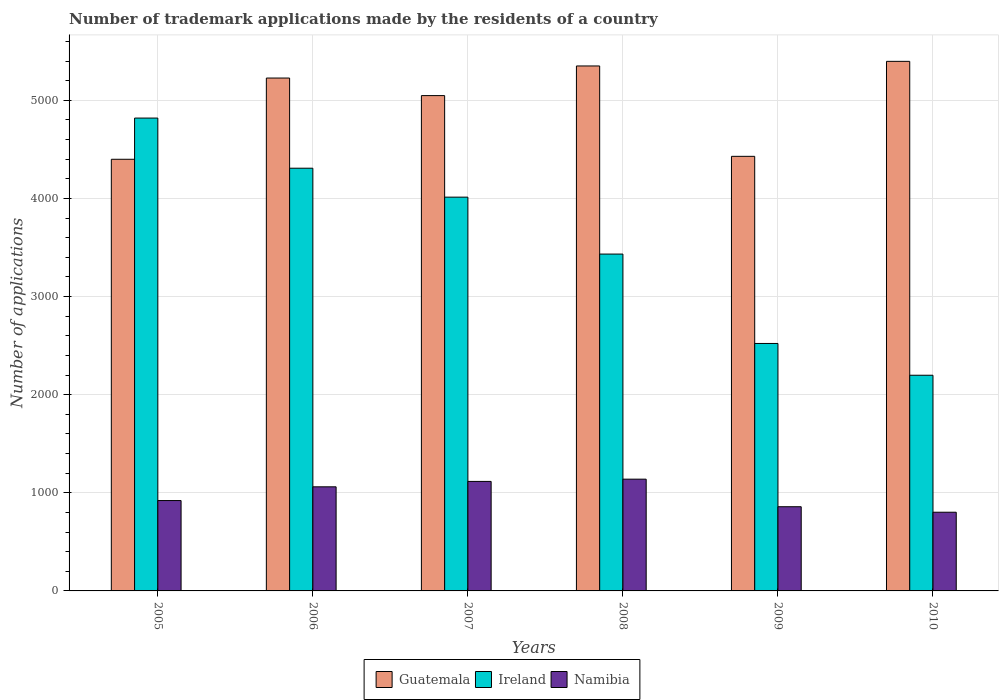Are the number of bars per tick equal to the number of legend labels?
Your answer should be very brief. Yes. Are the number of bars on each tick of the X-axis equal?
Keep it short and to the point. Yes. How many bars are there on the 6th tick from the left?
Give a very brief answer. 3. What is the label of the 5th group of bars from the left?
Provide a succinct answer. 2009. In how many cases, is the number of bars for a given year not equal to the number of legend labels?
Offer a terse response. 0. What is the number of trademark applications made by the residents in Guatemala in 2009?
Your answer should be very brief. 4429. Across all years, what is the maximum number of trademark applications made by the residents in Guatemala?
Offer a terse response. 5397. Across all years, what is the minimum number of trademark applications made by the residents in Guatemala?
Provide a succinct answer. 4399. In which year was the number of trademark applications made by the residents in Namibia maximum?
Provide a short and direct response. 2008. In which year was the number of trademark applications made by the residents in Guatemala minimum?
Give a very brief answer. 2005. What is the total number of trademark applications made by the residents in Ireland in the graph?
Give a very brief answer. 2.13e+04. What is the difference between the number of trademark applications made by the residents in Ireland in 2007 and that in 2010?
Give a very brief answer. 1815. What is the difference between the number of trademark applications made by the residents in Ireland in 2007 and the number of trademark applications made by the residents in Namibia in 2005?
Make the answer very short. 3092. What is the average number of trademark applications made by the residents in Ireland per year?
Give a very brief answer. 3548.83. In the year 2005, what is the difference between the number of trademark applications made by the residents in Namibia and number of trademark applications made by the residents in Ireland?
Offer a very short reply. -3898. What is the ratio of the number of trademark applications made by the residents in Guatemala in 2005 to that in 2006?
Your answer should be very brief. 0.84. Is the number of trademark applications made by the residents in Namibia in 2005 less than that in 2006?
Provide a succinct answer. Yes. What is the difference between the highest and the second highest number of trademark applications made by the residents in Ireland?
Offer a terse response. 511. What is the difference between the highest and the lowest number of trademark applications made by the residents in Guatemala?
Make the answer very short. 998. In how many years, is the number of trademark applications made by the residents in Guatemala greater than the average number of trademark applications made by the residents in Guatemala taken over all years?
Provide a short and direct response. 4. Is the sum of the number of trademark applications made by the residents in Guatemala in 2006 and 2009 greater than the maximum number of trademark applications made by the residents in Ireland across all years?
Keep it short and to the point. Yes. What does the 1st bar from the left in 2006 represents?
Your answer should be very brief. Guatemala. What does the 1st bar from the right in 2010 represents?
Your response must be concise. Namibia. Is it the case that in every year, the sum of the number of trademark applications made by the residents in Namibia and number of trademark applications made by the residents in Guatemala is greater than the number of trademark applications made by the residents in Ireland?
Your answer should be very brief. Yes. How many bars are there?
Offer a terse response. 18. How many years are there in the graph?
Offer a very short reply. 6. What is the difference between two consecutive major ticks on the Y-axis?
Your response must be concise. 1000. Are the values on the major ticks of Y-axis written in scientific E-notation?
Offer a very short reply. No. Does the graph contain any zero values?
Make the answer very short. No. Where does the legend appear in the graph?
Your answer should be compact. Bottom center. What is the title of the graph?
Your answer should be compact. Number of trademark applications made by the residents of a country. Does "Papua New Guinea" appear as one of the legend labels in the graph?
Give a very brief answer. No. What is the label or title of the Y-axis?
Your response must be concise. Number of applications. What is the Number of applications of Guatemala in 2005?
Provide a succinct answer. 4399. What is the Number of applications in Ireland in 2005?
Your answer should be compact. 4819. What is the Number of applications in Namibia in 2005?
Keep it short and to the point. 921. What is the Number of applications in Guatemala in 2006?
Make the answer very short. 5227. What is the Number of applications in Ireland in 2006?
Offer a terse response. 4308. What is the Number of applications in Namibia in 2006?
Offer a very short reply. 1061. What is the Number of applications of Guatemala in 2007?
Provide a succinct answer. 5048. What is the Number of applications in Ireland in 2007?
Your response must be concise. 4013. What is the Number of applications of Namibia in 2007?
Make the answer very short. 1116. What is the Number of applications of Guatemala in 2008?
Make the answer very short. 5350. What is the Number of applications in Ireland in 2008?
Provide a short and direct response. 3433. What is the Number of applications of Namibia in 2008?
Your answer should be compact. 1139. What is the Number of applications in Guatemala in 2009?
Offer a very short reply. 4429. What is the Number of applications of Ireland in 2009?
Your answer should be compact. 2522. What is the Number of applications in Namibia in 2009?
Provide a succinct answer. 858. What is the Number of applications in Guatemala in 2010?
Ensure brevity in your answer.  5397. What is the Number of applications in Ireland in 2010?
Keep it short and to the point. 2198. What is the Number of applications of Namibia in 2010?
Ensure brevity in your answer.  802. Across all years, what is the maximum Number of applications in Guatemala?
Provide a succinct answer. 5397. Across all years, what is the maximum Number of applications of Ireland?
Provide a short and direct response. 4819. Across all years, what is the maximum Number of applications in Namibia?
Offer a very short reply. 1139. Across all years, what is the minimum Number of applications of Guatemala?
Offer a very short reply. 4399. Across all years, what is the minimum Number of applications in Ireland?
Keep it short and to the point. 2198. Across all years, what is the minimum Number of applications of Namibia?
Ensure brevity in your answer.  802. What is the total Number of applications in Guatemala in the graph?
Give a very brief answer. 2.98e+04. What is the total Number of applications in Ireland in the graph?
Give a very brief answer. 2.13e+04. What is the total Number of applications in Namibia in the graph?
Your response must be concise. 5897. What is the difference between the Number of applications of Guatemala in 2005 and that in 2006?
Ensure brevity in your answer.  -828. What is the difference between the Number of applications of Ireland in 2005 and that in 2006?
Ensure brevity in your answer.  511. What is the difference between the Number of applications of Namibia in 2005 and that in 2006?
Make the answer very short. -140. What is the difference between the Number of applications in Guatemala in 2005 and that in 2007?
Offer a terse response. -649. What is the difference between the Number of applications of Ireland in 2005 and that in 2007?
Your response must be concise. 806. What is the difference between the Number of applications of Namibia in 2005 and that in 2007?
Give a very brief answer. -195. What is the difference between the Number of applications in Guatemala in 2005 and that in 2008?
Provide a succinct answer. -951. What is the difference between the Number of applications in Ireland in 2005 and that in 2008?
Ensure brevity in your answer.  1386. What is the difference between the Number of applications of Namibia in 2005 and that in 2008?
Offer a terse response. -218. What is the difference between the Number of applications of Guatemala in 2005 and that in 2009?
Make the answer very short. -30. What is the difference between the Number of applications in Ireland in 2005 and that in 2009?
Offer a terse response. 2297. What is the difference between the Number of applications of Guatemala in 2005 and that in 2010?
Ensure brevity in your answer.  -998. What is the difference between the Number of applications of Ireland in 2005 and that in 2010?
Offer a terse response. 2621. What is the difference between the Number of applications in Namibia in 2005 and that in 2010?
Give a very brief answer. 119. What is the difference between the Number of applications of Guatemala in 2006 and that in 2007?
Your answer should be compact. 179. What is the difference between the Number of applications in Ireland in 2006 and that in 2007?
Ensure brevity in your answer.  295. What is the difference between the Number of applications in Namibia in 2006 and that in 2007?
Ensure brevity in your answer.  -55. What is the difference between the Number of applications in Guatemala in 2006 and that in 2008?
Provide a succinct answer. -123. What is the difference between the Number of applications of Ireland in 2006 and that in 2008?
Provide a short and direct response. 875. What is the difference between the Number of applications in Namibia in 2006 and that in 2008?
Give a very brief answer. -78. What is the difference between the Number of applications of Guatemala in 2006 and that in 2009?
Give a very brief answer. 798. What is the difference between the Number of applications of Ireland in 2006 and that in 2009?
Your response must be concise. 1786. What is the difference between the Number of applications in Namibia in 2006 and that in 2009?
Your answer should be very brief. 203. What is the difference between the Number of applications in Guatemala in 2006 and that in 2010?
Offer a terse response. -170. What is the difference between the Number of applications of Ireland in 2006 and that in 2010?
Offer a terse response. 2110. What is the difference between the Number of applications of Namibia in 2006 and that in 2010?
Keep it short and to the point. 259. What is the difference between the Number of applications in Guatemala in 2007 and that in 2008?
Your answer should be compact. -302. What is the difference between the Number of applications in Ireland in 2007 and that in 2008?
Give a very brief answer. 580. What is the difference between the Number of applications of Guatemala in 2007 and that in 2009?
Provide a short and direct response. 619. What is the difference between the Number of applications in Ireland in 2007 and that in 2009?
Your answer should be compact. 1491. What is the difference between the Number of applications in Namibia in 2007 and that in 2009?
Provide a short and direct response. 258. What is the difference between the Number of applications in Guatemala in 2007 and that in 2010?
Your response must be concise. -349. What is the difference between the Number of applications of Ireland in 2007 and that in 2010?
Provide a short and direct response. 1815. What is the difference between the Number of applications in Namibia in 2007 and that in 2010?
Provide a short and direct response. 314. What is the difference between the Number of applications of Guatemala in 2008 and that in 2009?
Your answer should be compact. 921. What is the difference between the Number of applications of Ireland in 2008 and that in 2009?
Provide a short and direct response. 911. What is the difference between the Number of applications of Namibia in 2008 and that in 2009?
Make the answer very short. 281. What is the difference between the Number of applications in Guatemala in 2008 and that in 2010?
Provide a succinct answer. -47. What is the difference between the Number of applications in Ireland in 2008 and that in 2010?
Give a very brief answer. 1235. What is the difference between the Number of applications in Namibia in 2008 and that in 2010?
Provide a succinct answer. 337. What is the difference between the Number of applications of Guatemala in 2009 and that in 2010?
Your answer should be compact. -968. What is the difference between the Number of applications of Ireland in 2009 and that in 2010?
Your answer should be compact. 324. What is the difference between the Number of applications in Namibia in 2009 and that in 2010?
Your answer should be very brief. 56. What is the difference between the Number of applications of Guatemala in 2005 and the Number of applications of Ireland in 2006?
Provide a succinct answer. 91. What is the difference between the Number of applications in Guatemala in 2005 and the Number of applications in Namibia in 2006?
Your response must be concise. 3338. What is the difference between the Number of applications in Ireland in 2005 and the Number of applications in Namibia in 2006?
Keep it short and to the point. 3758. What is the difference between the Number of applications in Guatemala in 2005 and the Number of applications in Ireland in 2007?
Make the answer very short. 386. What is the difference between the Number of applications in Guatemala in 2005 and the Number of applications in Namibia in 2007?
Offer a very short reply. 3283. What is the difference between the Number of applications in Ireland in 2005 and the Number of applications in Namibia in 2007?
Make the answer very short. 3703. What is the difference between the Number of applications in Guatemala in 2005 and the Number of applications in Ireland in 2008?
Offer a very short reply. 966. What is the difference between the Number of applications in Guatemala in 2005 and the Number of applications in Namibia in 2008?
Ensure brevity in your answer.  3260. What is the difference between the Number of applications in Ireland in 2005 and the Number of applications in Namibia in 2008?
Your answer should be compact. 3680. What is the difference between the Number of applications in Guatemala in 2005 and the Number of applications in Ireland in 2009?
Offer a terse response. 1877. What is the difference between the Number of applications in Guatemala in 2005 and the Number of applications in Namibia in 2009?
Provide a short and direct response. 3541. What is the difference between the Number of applications of Ireland in 2005 and the Number of applications of Namibia in 2009?
Give a very brief answer. 3961. What is the difference between the Number of applications in Guatemala in 2005 and the Number of applications in Ireland in 2010?
Your response must be concise. 2201. What is the difference between the Number of applications of Guatemala in 2005 and the Number of applications of Namibia in 2010?
Make the answer very short. 3597. What is the difference between the Number of applications of Ireland in 2005 and the Number of applications of Namibia in 2010?
Keep it short and to the point. 4017. What is the difference between the Number of applications in Guatemala in 2006 and the Number of applications in Ireland in 2007?
Offer a terse response. 1214. What is the difference between the Number of applications in Guatemala in 2006 and the Number of applications in Namibia in 2007?
Make the answer very short. 4111. What is the difference between the Number of applications of Ireland in 2006 and the Number of applications of Namibia in 2007?
Make the answer very short. 3192. What is the difference between the Number of applications in Guatemala in 2006 and the Number of applications in Ireland in 2008?
Give a very brief answer. 1794. What is the difference between the Number of applications of Guatemala in 2006 and the Number of applications of Namibia in 2008?
Provide a short and direct response. 4088. What is the difference between the Number of applications in Ireland in 2006 and the Number of applications in Namibia in 2008?
Offer a terse response. 3169. What is the difference between the Number of applications in Guatemala in 2006 and the Number of applications in Ireland in 2009?
Your answer should be compact. 2705. What is the difference between the Number of applications in Guatemala in 2006 and the Number of applications in Namibia in 2009?
Your answer should be compact. 4369. What is the difference between the Number of applications in Ireland in 2006 and the Number of applications in Namibia in 2009?
Ensure brevity in your answer.  3450. What is the difference between the Number of applications of Guatemala in 2006 and the Number of applications of Ireland in 2010?
Ensure brevity in your answer.  3029. What is the difference between the Number of applications in Guatemala in 2006 and the Number of applications in Namibia in 2010?
Ensure brevity in your answer.  4425. What is the difference between the Number of applications in Ireland in 2006 and the Number of applications in Namibia in 2010?
Provide a succinct answer. 3506. What is the difference between the Number of applications of Guatemala in 2007 and the Number of applications of Ireland in 2008?
Offer a very short reply. 1615. What is the difference between the Number of applications of Guatemala in 2007 and the Number of applications of Namibia in 2008?
Offer a terse response. 3909. What is the difference between the Number of applications in Ireland in 2007 and the Number of applications in Namibia in 2008?
Provide a short and direct response. 2874. What is the difference between the Number of applications in Guatemala in 2007 and the Number of applications in Ireland in 2009?
Offer a very short reply. 2526. What is the difference between the Number of applications of Guatemala in 2007 and the Number of applications of Namibia in 2009?
Provide a short and direct response. 4190. What is the difference between the Number of applications of Ireland in 2007 and the Number of applications of Namibia in 2009?
Provide a succinct answer. 3155. What is the difference between the Number of applications of Guatemala in 2007 and the Number of applications of Ireland in 2010?
Your answer should be very brief. 2850. What is the difference between the Number of applications in Guatemala in 2007 and the Number of applications in Namibia in 2010?
Provide a succinct answer. 4246. What is the difference between the Number of applications in Ireland in 2007 and the Number of applications in Namibia in 2010?
Your answer should be compact. 3211. What is the difference between the Number of applications of Guatemala in 2008 and the Number of applications of Ireland in 2009?
Your response must be concise. 2828. What is the difference between the Number of applications in Guatemala in 2008 and the Number of applications in Namibia in 2009?
Offer a terse response. 4492. What is the difference between the Number of applications in Ireland in 2008 and the Number of applications in Namibia in 2009?
Ensure brevity in your answer.  2575. What is the difference between the Number of applications of Guatemala in 2008 and the Number of applications of Ireland in 2010?
Your answer should be compact. 3152. What is the difference between the Number of applications of Guatemala in 2008 and the Number of applications of Namibia in 2010?
Offer a terse response. 4548. What is the difference between the Number of applications in Ireland in 2008 and the Number of applications in Namibia in 2010?
Give a very brief answer. 2631. What is the difference between the Number of applications in Guatemala in 2009 and the Number of applications in Ireland in 2010?
Your response must be concise. 2231. What is the difference between the Number of applications of Guatemala in 2009 and the Number of applications of Namibia in 2010?
Give a very brief answer. 3627. What is the difference between the Number of applications of Ireland in 2009 and the Number of applications of Namibia in 2010?
Make the answer very short. 1720. What is the average Number of applications in Guatemala per year?
Keep it short and to the point. 4975. What is the average Number of applications in Ireland per year?
Provide a succinct answer. 3548.83. What is the average Number of applications in Namibia per year?
Your answer should be very brief. 982.83. In the year 2005, what is the difference between the Number of applications in Guatemala and Number of applications in Ireland?
Keep it short and to the point. -420. In the year 2005, what is the difference between the Number of applications of Guatemala and Number of applications of Namibia?
Provide a succinct answer. 3478. In the year 2005, what is the difference between the Number of applications in Ireland and Number of applications in Namibia?
Give a very brief answer. 3898. In the year 2006, what is the difference between the Number of applications of Guatemala and Number of applications of Ireland?
Give a very brief answer. 919. In the year 2006, what is the difference between the Number of applications in Guatemala and Number of applications in Namibia?
Provide a succinct answer. 4166. In the year 2006, what is the difference between the Number of applications in Ireland and Number of applications in Namibia?
Your response must be concise. 3247. In the year 2007, what is the difference between the Number of applications in Guatemala and Number of applications in Ireland?
Give a very brief answer. 1035. In the year 2007, what is the difference between the Number of applications in Guatemala and Number of applications in Namibia?
Keep it short and to the point. 3932. In the year 2007, what is the difference between the Number of applications of Ireland and Number of applications of Namibia?
Provide a succinct answer. 2897. In the year 2008, what is the difference between the Number of applications of Guatemala and Number of applications of Ireland?
Keep it short and to the point. 1917. In the year 2008, what is the difference between the Number of applications of Guatemala and Number of applications of Namibia?
Keep it short and to the point. 4211. In the year 2008, what is the difference between the Number of applications of Ireland and Number of applications of Namibia?
Offer a terse response. 2294. In the year 2009, what is the difference between the Number of applications of Guatemala and Number of applications of Ireland?
Keep it short and to the point. 1907. In the year 2009, what is the difference between the Number of applications of Guatemala and Number of applications of Namibia?
Offer a terse response. 3571. In the year 2009, what is the difference between the Number of applications of Ireland and Number of applications of Namibia?
Make the answer very short. 1664. In the year 2010, what is the difference between the Number of applications in Guatemala and Number of applications in Ireland?
Provide a succinct answer. 3199. In the year 2010, what is the difference between the Number of applications of Guatemala and Number of applications of Namibia?
Provide a short and direct response. 4595. In the year 2010, what is the difference between the Number of applications of Ireland and Number of applications of Namibia?
Make the answer very short. 1396. What is the ratio of the Number of applications of Guatemala in 2005 to that in 2006?
Your answer should be very brief. 0.84. What is the ratio of the Number of applications of Ireland in 2005 to that in 2006?
Your answer should be very brief. 1.12. What is the ratio of the Number of applications in Namibia in 2005 to that in 2006?
Make the answer very short. 0.87. What is the ratio of the Number of applications in Guatemala in 2005 to that in 2007?
Your response must be concise. 0.87. What is the ratio of the Number of applications of Ireland in 2005 to that in 2007?
Provide a short and direct response. 1.2. What is the ratio of the Number of applications of Namibia in 2005 to that in 2007?
Your answer should be very brief. 0.83. What is the ratio of the Number of applications in Guatemala in 2005 to that in 2008?
Provide a succinct answer. 0.82. What is the ratio of the Number of applications of Ireland in 2005 to that in 2008?
Provide a short and direct response. 1.4. What is the ratio of the Number of applications of Namibia in 2005 to that in 2008?
Provide a short and direct response. 0.81. What is the ratio of the Number of applications of Ireland in 2005 to that in 2009?
Your answer should be compact. 1.91. What is the ratio of the Number of applications of Namibia in 2005 to that in 2009?
Make the answer very short. 1.07. What is the ratio of the Number of applications in Guatemala in 2005 to that in 2010?
Make the answer very short. 0.82. What is the ratio of the Number of applications of Ireland in 2005 to that in 2010?
Make the answer very short. 2.19. What is the ratio of the Number of applications in Namibia in 2005 to that in 2010?
Ensure brevity in your answer.  1.15. What is the ratio of the Number of applications in Guatemala in 2006 to that in 2007?
Give a very brief answer. 1.04. What is the ratio of the Number of applications in Ireland in 2006 to that in 2007?
Keep it short and to the point. 1.07. What is the ratio of the Number of applications of Namibia in 2006 to that in 2007?
Keep it short and to the point. 0.95. What is the ratio of the Number of applications of Ireland in 2006 to that in 2008?
Your answer should be compact. 1.25. What is the ratio of the Number of applications in Namibia in 2006 to that in 2008?
Provide a short and direct response. 0.93. What is the ratio of the Number of applications of Guatemala in 2006 to that in 2009?
Give a very brief answer. 1.18. What is the ratio of the Number of applications of Ireland in 2006 to that in 2009?
Provide a succinct answer. 1.71. What is the ratio of the Number of applications of Namibia in 2006 to that in 2009?
Ensure brevity in your answer.  1.24. What is the ratio of the Number of applications of Guatemala in 2006 to that in 2010?
Make the answer very short. 0.97. What is the ratio of the Number of applications in Ireland in 2006 to that in 2010?
Your answer should be compact. 1.96. What is the ratio of the Number of applications in Namibia in 2006 to that in 2010?
Your answer should be compact. 1.32. What is the ratio of the Number of applications in Guatemala in 2007 to that in 2008?
Offer a very short reply. 0.94. What is the ratio of the Number of applications of Ireland in 2007 to that in 2008?
Offer a very short reply. 1.17. What is the ratio of the Number of applications of Namibia in 2007 to that in 2008?
Your answer should be very brief. 0.98. What is the ratio of the Number of applications in Guatemala in 2007 to that in 2009?
Ensure brevity in your answer.  1.14. What is the ratio of the Number of applications of Ireland in 2007 to that in 2009?
Provide a succinct answer. 1.59. What is the ratio of the Number of applications of Namibia in 2007 to that in 2009?
Ensure brevity in your answer.  1.3. What is the ratio of the Number of applications in Guatemala in 2007 to that in 2010?
Provide a short and direct response. 0.94. What is the ratio of the Number of applications of Ireland in 2007 to that in 2010?
Keep it short and to the point. 1.83. What is the ratio of the Number of applications in Namibia in 2007 to that in 2010?
Ensure brevity in your answer.  1.39. What is the ratio of the Number of applications of Guatemala in 2008 to that in 2009?
Offer a very short reply. 1.21. What is the ratio of the Number of applications of Ireland in 2008 to that in 2009?
Keep it short and to the point. 1.36. What is the ratio of the Number of applications in Namibia in 2008 to that in 2009?
Make the answer very short. 1.33. What is the ratio of the Number of applications of Guatemala in 2008 to that in 2010?
Make the answer very short. 0.99. What is the ratio of the Number of applications in Ireland in 2008 to that in 2010?
Provide a short and direct response. 1.56. What is the ratio of the Number of applications in Namibia in 2008 to that in 2010?
Offer a terse response. 1.42. What is the ratio of the Number of applications of Guatemala in 2009 to that in 2010?
Your answer should be compact. 0.82. What is the ratio of the Number of applications of Ireland in 2009 to that in 2010?
Your response must be concise. 1.15. What is the ratio of the Number of applications in Namibia in 2009 to that in 2010?
Your answer should be compact. 1.07. What is the difference between the highest and the second highest Number of applications of Ireland?
Ensure brevity in your answer.  511. What is the difference between the highest and the second highest Number of applications of Namibia?
Provide a succinct answer. 23. What is the difference between the highest and the lowest Number of applications in Guatemala?
Your answer should be very brief. 998. What is the difference between the highest and the lowest Number of applications of Ireland?
Ensure brevity in your answer.  2621. What is the difference between the highest and the lowest Number of applications of Namibia?
Your answer should be compact. 337. 